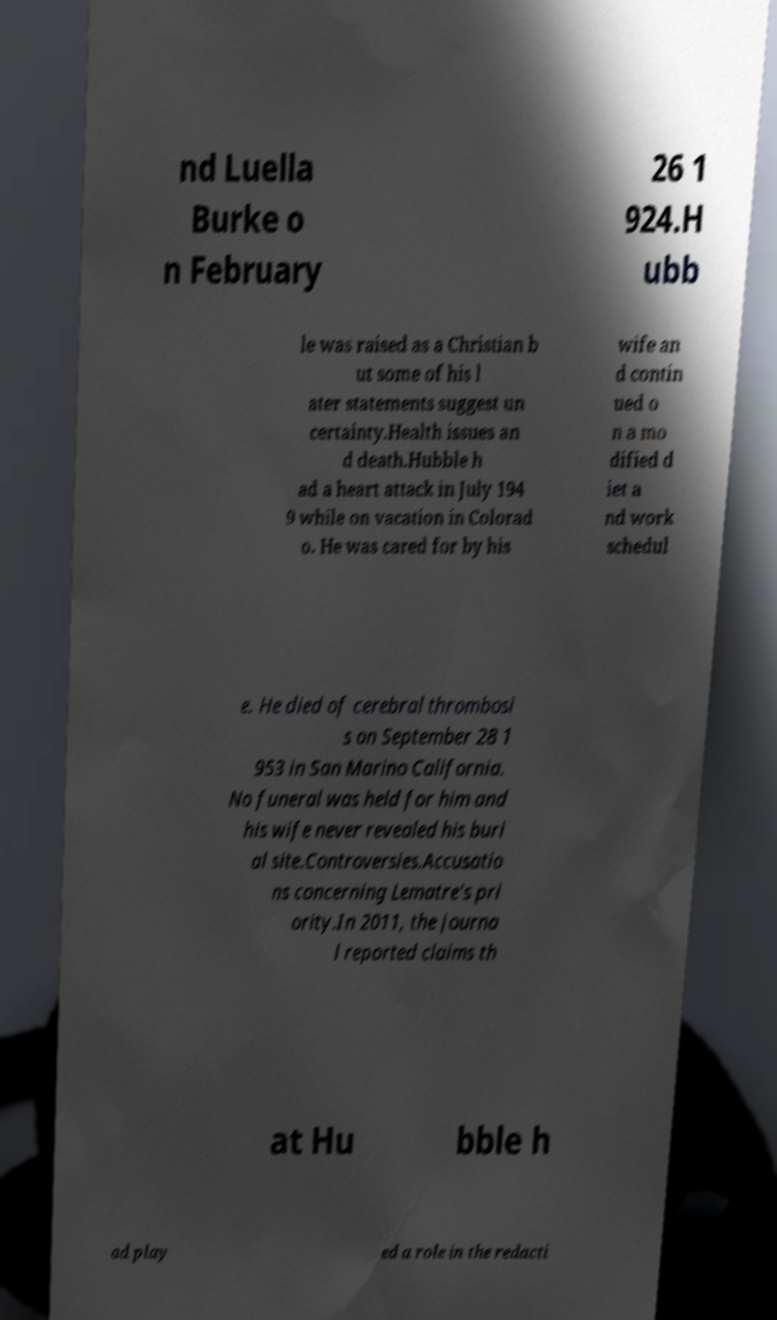For documentation purposes, I need the text within this image transcribed. Could you provide that? nd Luella Burke o n February 26 1 924.H ubb le was raised as a Christian b ut some of his l ater statements suggest un certainty.Health issues an d death.Hubble h ad a heart attack in July 194 9 while on vacation in Colorad o. He was cared for by his wife an d contin ued o n a mo dified d iet a nd work schedul e. He died of cerebral thrombosi s on September 28 1 953 in San Marino California. No funeral was held for him and his wife never revealed his buri al site.Controversies.Accusatio ns concerning Lematre's pri ority.In 2011, the journa l reported claims th at Hu bble h ad play ed a role in the redacti 